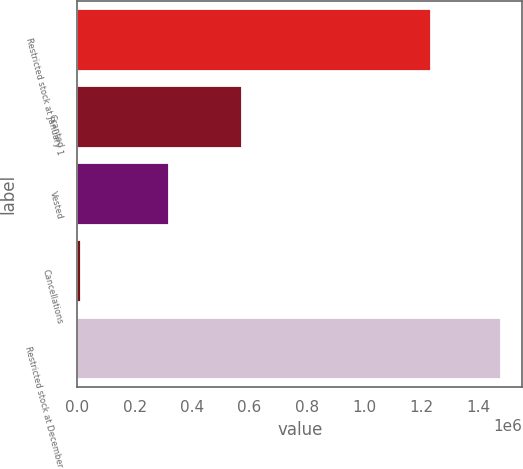Convert chart. <chart><loc_0><loc_0><loc_500><loc_500><bar_chart><fcel>Restricted stock at January 1<fcel>Granted<fcel>Vested<fcel>Cancellations<fcel>Restricted stock at December<nl><fcel>1.2355e+06<fcel>573440<fcel>318350<fcel>12595<fcel>1.478e+06<nl></chart> 